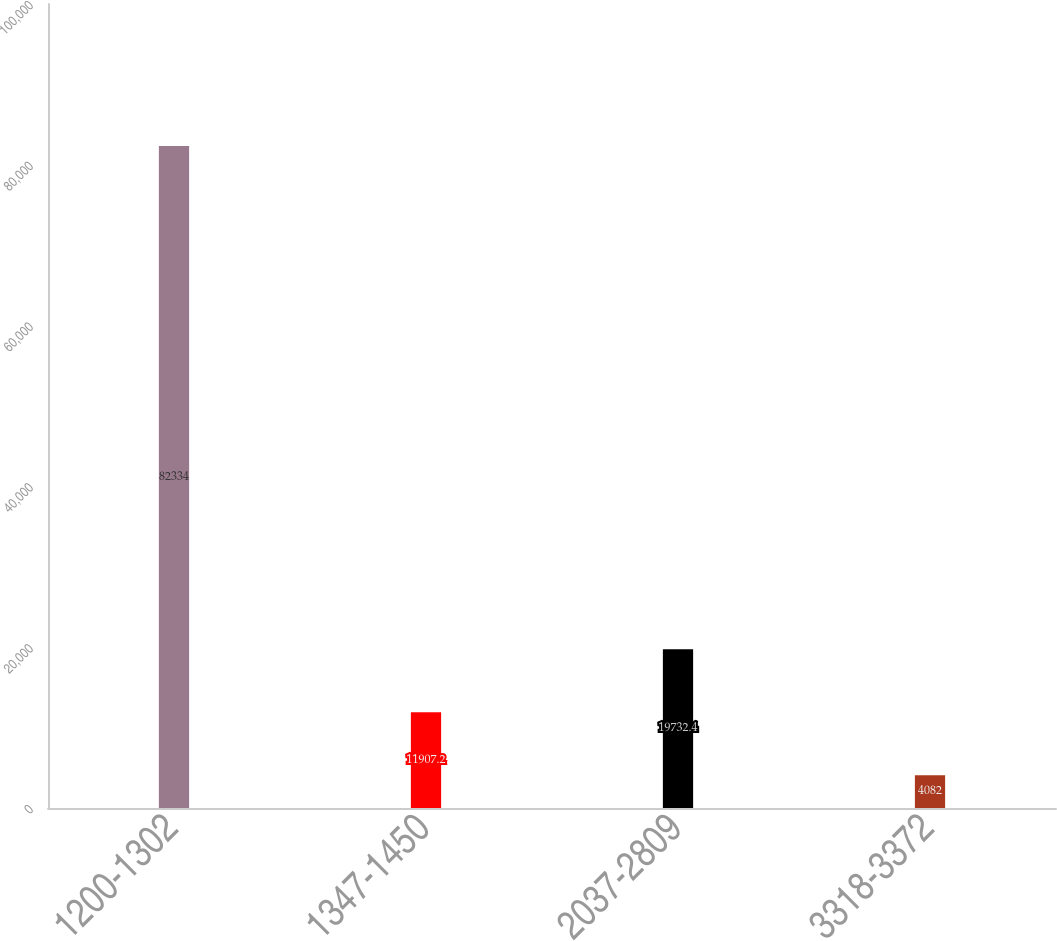Convert chart to OTSL. <chart><loc_0><loc_0><loc_500><loc_500><bar_chart><fcel>1200-1302<fcel>1347-1450<fcel>2037-2809<fcel>3318-3372<nl><fcel>82334<fcel>11907.2<fcel>19732.4<fcel>4082<nl></chart> 